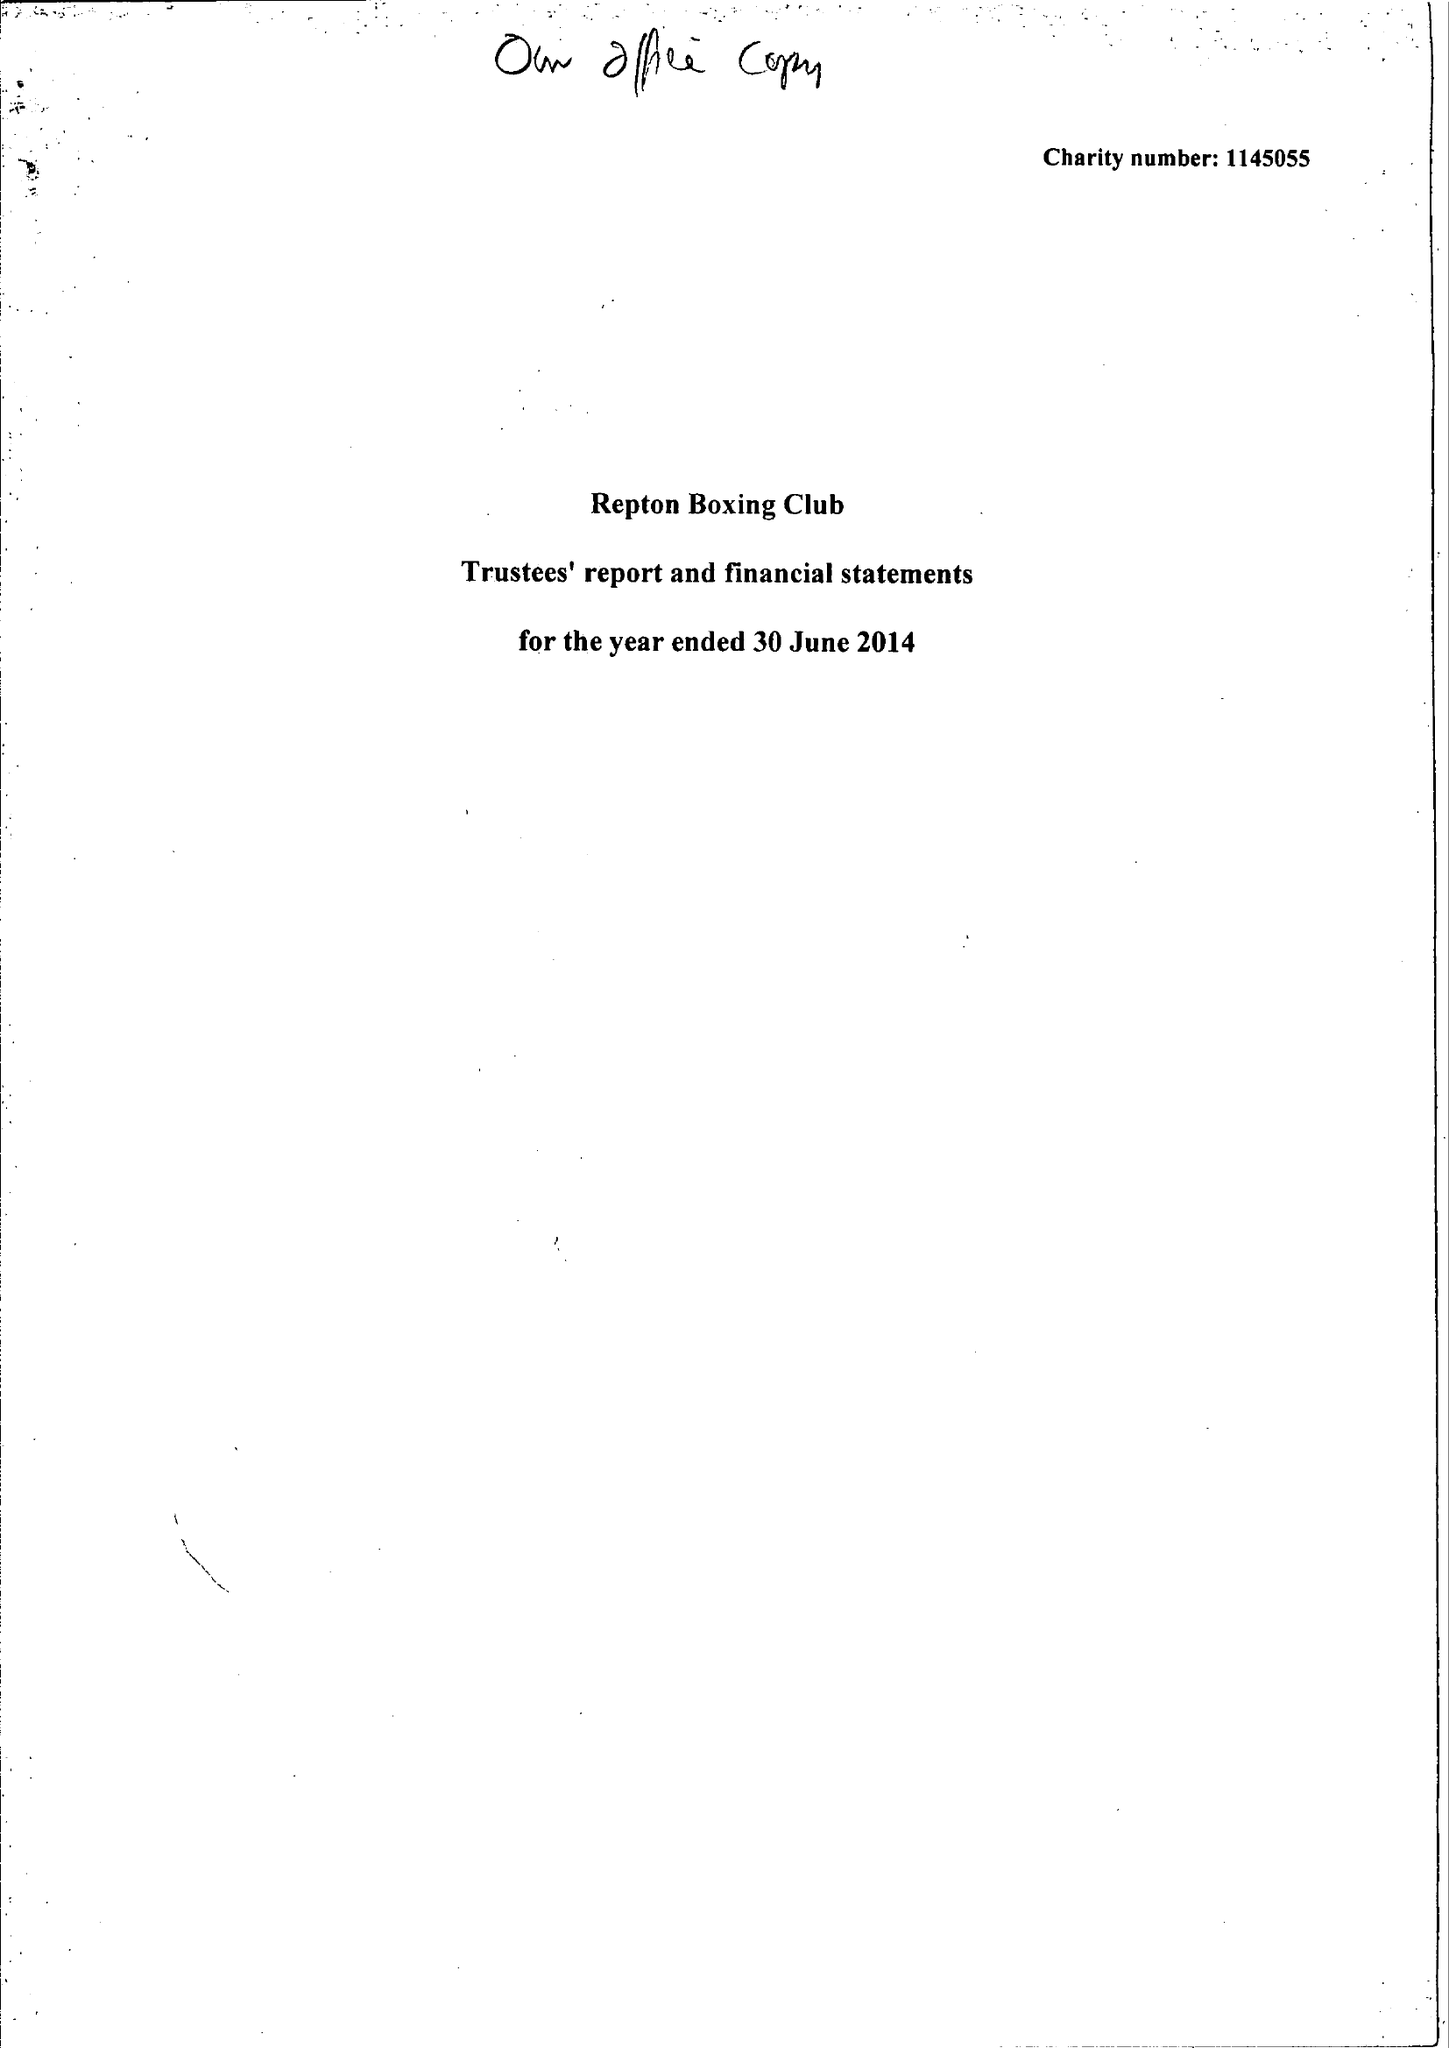What is the value for the income_annually_in_british_pounds?
Answer the question using a single word or phrase. 89421.00 